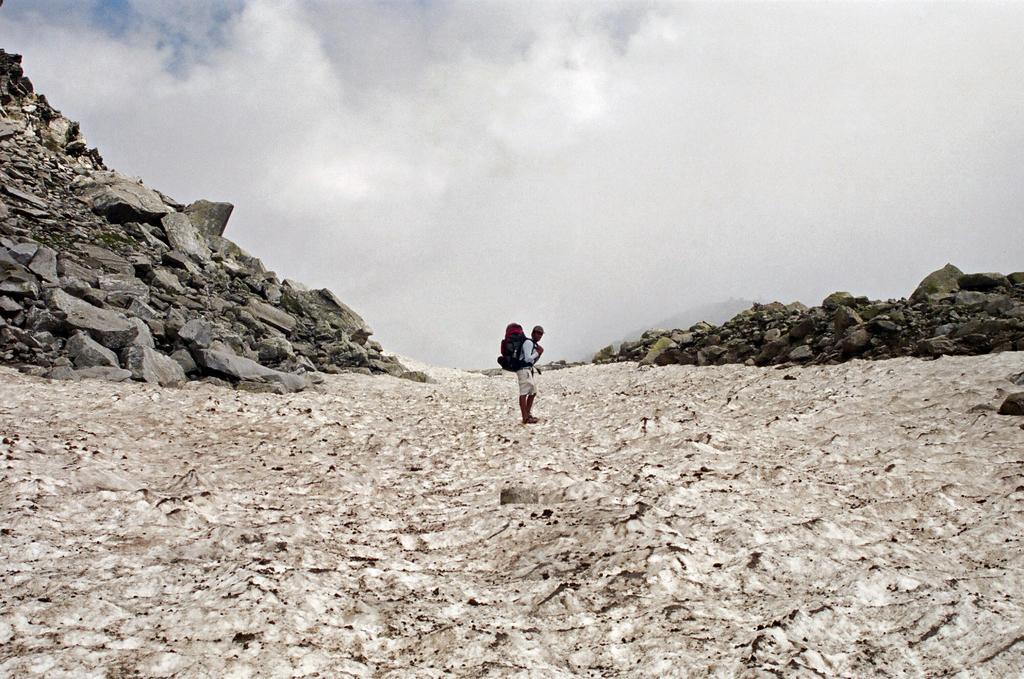Can you describe this image briefly? In this image I can see a person is standing in centre of this image. I can also see number of stones on both side of this image. In the background I can see clouds and the sky. 